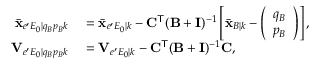<formula> <loc_0><loc_0><loc_500><loc_500>\begin{array} { r l } { \bar { x } _ { e ^ { \prime } E _ { 0 } | q _ { B } p _ { B } k } } & = \bar { x } _ { e ^ { \prime } E _ { 0 } | k } - C ^ { T } ( B + I ) ^ { - 1 } \left [ \bar { x } _ { B | k } - \left ( \begin{array} { l } { q _ { B } } \\ { p _ { B } } \end{array} \right ) \right ] , } \\ { V _ { e ^ { \prime } E _ { 0 } | q _ { B } p _ { B } k } } & = V _ { e ^ { \prime } E _ { 0 } | k } - C ^ { T } ( B + I ) ^ { - 1 } C , } \end{array}</formula> 